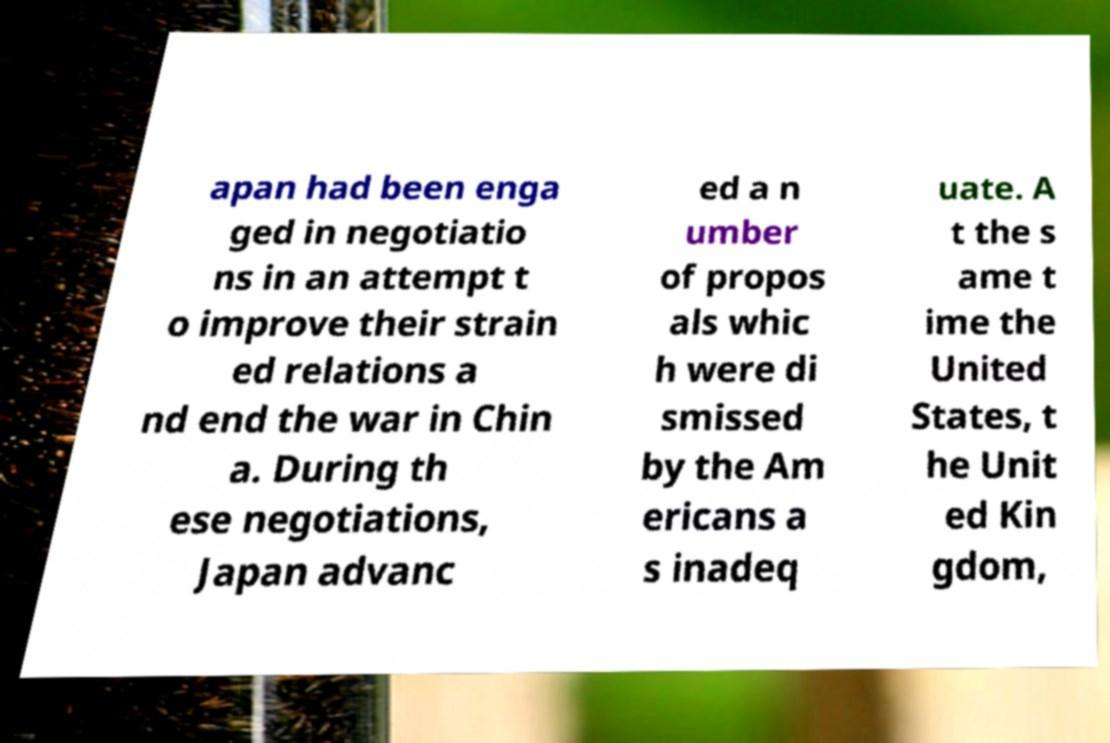Please identify and transcribe the text found in this image. apan had been enga ged in negotiatio ns in an attempt t o improve their strain ed relations a nd end the war in Chin a. During th ese negotiations, Japan advanc ed a n umber of propos als whic h were di smissed by the Am ericans a s inadeq uate. A t the s ame t ime the United States, t he Unit ed Kin gdom, 